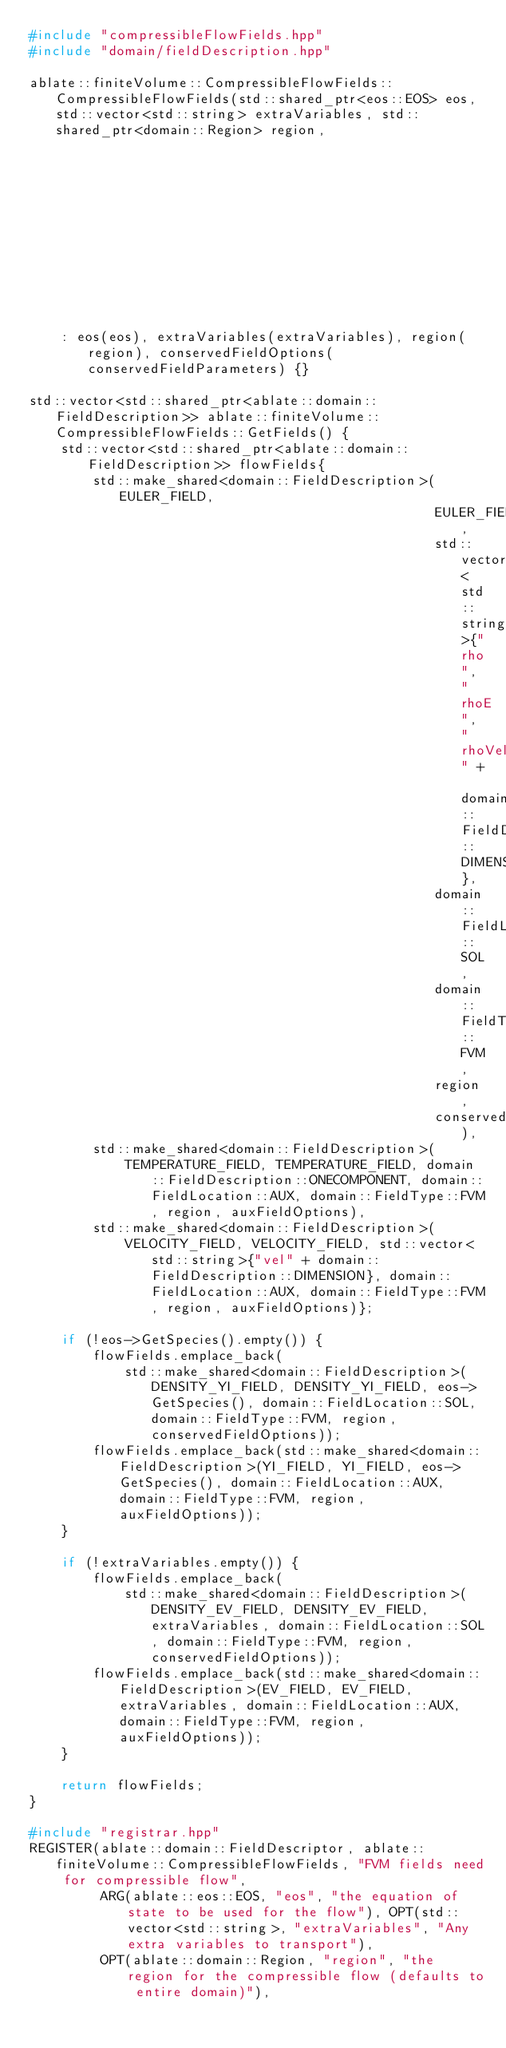Convert code to text. <code><loc_0><loc_0><loc_500><loc_500><_C++_>#include "compressibleFlowFields.hpp"
#include "domain/fieldDescription.hpp"

ablate::finiteVolume::CompressibleFlowFields::CompressibleFlowFields(std::shared_ptr<eos::EOS> eos, std::vector<std::string> extraVariables, std::shared_ptr<domain::Region> region,
                                                                     std::shared_ptr<parameters::Parameters> conservedFieldParameters)
    : eos(eos), extraVariables(extraVariables), region(region), conservedFieldOptions(conservedFieldParameters) {}

std::vector<std::shared_ptr<ablate::domain::FieldDescription>> ablate::finiteVolume::CompressibleFlowFields::GetFields() {
    std::vector<std::shared_ptr<ablate::domain::FieldDescription>> flowFields{
        std::make_shared<domain::FieldDescription>(EULER_FIELD,
                                                   EULER_FIELD,
                                                   std::vector<std::string>{"rho", "rhoE", "rhoVel" + domain::FieldDescription::DIMENSION},
                                                   domain::FieldLocation::SOL,
                                                   domain::FieldType::FVM,
                                                   region,
                                                   conservedFieldOptions),
        std::make_shared<domain::FieldDescription>(
            TEMPERATURE_FIELD, TEMPERATURE_FIELD, domain::FieldDescription::ONECOMPONENT, domain::FieldLocation::AUX, domain::FieldType::FVM, region, auxFieldOptions),
        std::make_shared<domain::FieldDescription>(
            VELOCITY_FIELD, VELOCITY_FIELD, std::vector<std::string>{"vel" + domain::FieldDescription::DIMENSION}, domain::FieldLocation::AUX, domain::FieldType::FVM, region, auxFieldOptions)};

    if (!eos->GetSpecies().empty()) {
        flowFields.emplace_back(
            std::make_shared<domain::FieldDescription>(DENSITY_YI_FIELD, DENSITY_YI_FIELD, eos->GetSpecies(), domain::FieldLocation::SOL, domain::FieldType::FVM, region, conservedFieldOptions));
        flowFields.emplace_back(std::make_shared<domain::FieldDescription>(YI_FIELD, YI_FIELD, eos->GetSpecies(), domain::FieldLocation::AUX, domain::FieldType::FVM, region, auxFieldOptions));
    }

    if (!extraVariables.empty()) {
        flowFields.emplace_back(
            std::make_shared<domain::FieldDescription>(DENSITY_EV_FIELD, DENSITY_EV_FIELD, extraVariables, domain::FieldLocation::SOL, domain::FieldType::FVM, region, conservedFieldOptions));
        flowFields.emplace_back(std::make_shared<domain::FieldDescription>(EV_FIELD, EV_FIELD, extraVariables, domain::FieldLocation::AUX, domain::FieldType::FVM, region, auxFieldOptions));
    }

    return flowFields;
}

#include "registrar.hpp"
REGISTER(ablate::domain::FieldDescriptor, ablate::finiteVolume::CompressibleFlowFields, "FVM fields need for compressible flow",
         ARG(ablate::eos::EOS, "eos", "the equation of state to be used for the flow"), OPT(std::vector<std::string>, "extraVariables", "Any extra variables to transport"),
         OPT(ablate::domain::Region, "region", "the region for the compressible flow (defaults to entire domain)"),</code> 